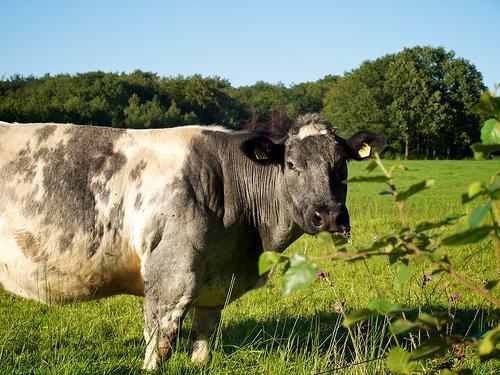How many animals are in this picture?
Give a very brief answer. 1. How many cows are pictured?
Give a very brief answer. 1. 